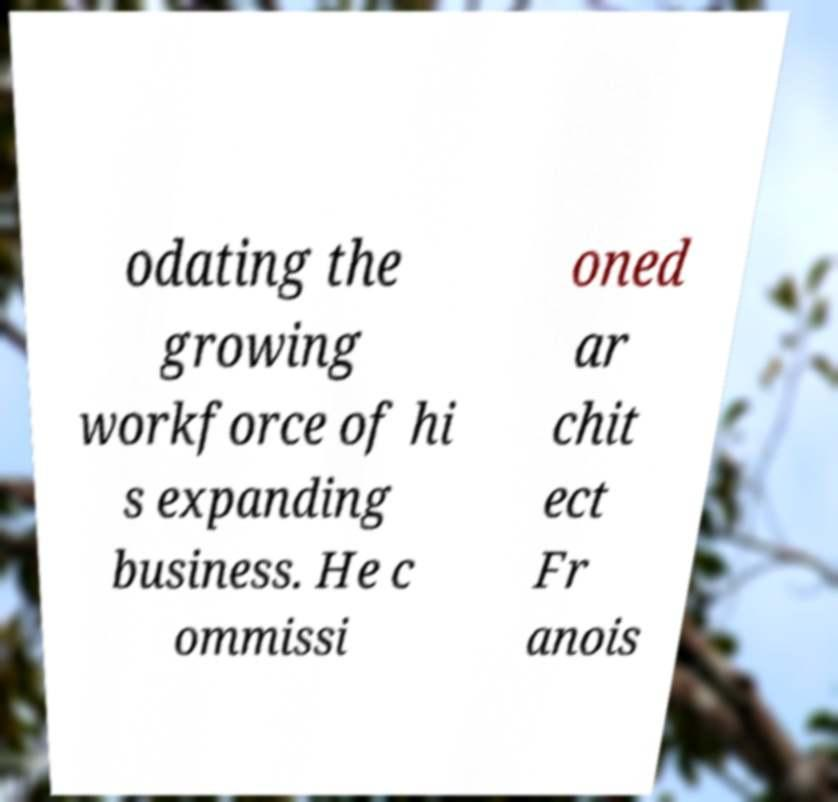I need the written content from this picture converted into text. Can you do that? odating the growing workforce of hi s expanding business. He c ommissi oned ar chit ect Fr anois 